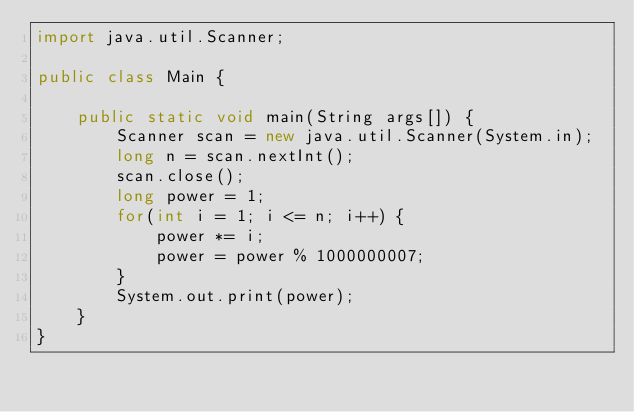<code> <loc_0><loc_0><loc_500><loc_500><_Java_>import java.util.Scanner;

public class Main {

	public static void main(String args[]) {
		Scanner scan = new java.util.Scanner(System.in);
		long n = scan.nextInt();
		scan.close();
		long power = 1;
		for(int i = 1; i <= n; i++) {
			power *= i;
			power = power % 1000000007;
		}
		System.out.print(power);
	}
}</code> 